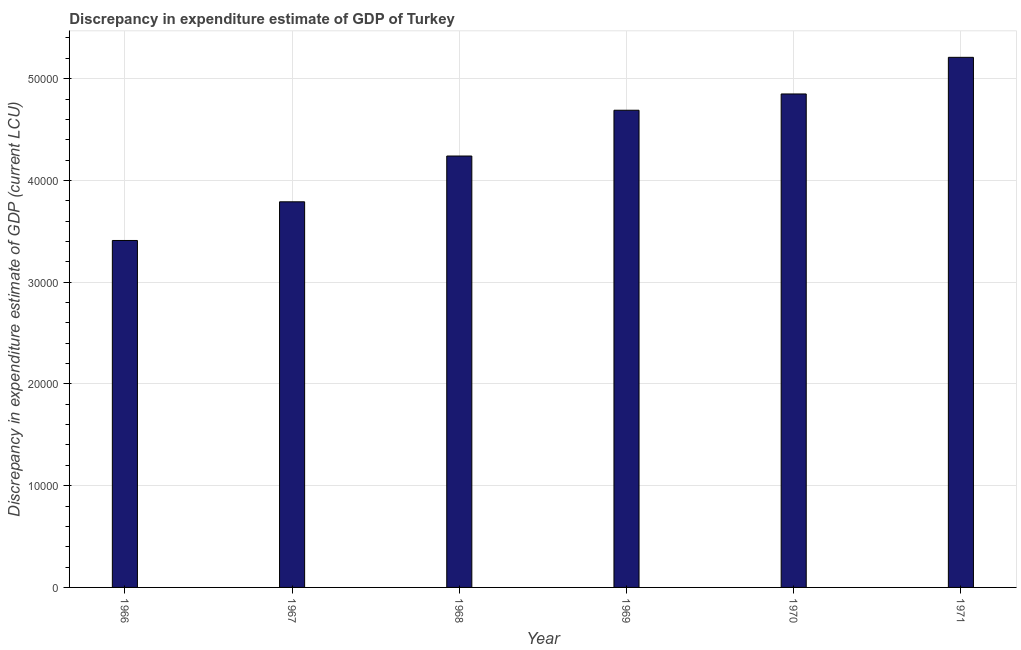Does the graph contain grids?
Provide a succinct answer. Yes. What is the title of the graph?
Make the answer very short. Discrepancy in expenditure estimate of GDP of Turkey. What is the label or title of the Y-axis?
Your answer should be compact. Discrepancy in expenditure estimate of GDP (current LCU). What is the discrepancy in expenditure estimate of gdp in 1968?
Give a very brief answer. 4.24e+04. Across all years, what is the maximum discrepancy in expenditure estimate of gdp?
Keep it short and to the point. 5.21e+04. Across all years, what is the minimum discrepancy in expenditure estimate of gdp?
Provide a succinct answer. 3.41e+04. In which year was the discrepancy in expenditure estimate of gdp maximum?
Your response must be concise. 1971. In which year was the discrepancy in expenditure estimate of gdp minimum?
Offer a very short reply. 1966. What is the sum of the discrepancy in expenditure estimate of gdp?
Keep it short and to the point. 2.62e+05. What is the difference between the discrepancy in expenditure estimate of gdp in 1969 and 1971?
Your response must be concise. -5200. What is the average discrepancy in expenditure estimate of gdp per year?
Offer a terse response. 4.36e+04. What is the median discrepancy in expenditure estimate of gdp?
Give a very brief answer. 4.46e+04. Do a majority of the years between 1967 and 1968 (inclusive) have discrepancy in expenditure estimate of gdp greater than 12000 LCU?
Offer a terse response. Yes. What is the ratio of the discrepancy in expenditure estimate of gdp in 1968 to that in 1970?
Make the answer very short. 0.87. Is the discrepancy in expenditure estimate of gdp in 1967 less than that in 1971?
Provide a short and direct response. Yes. Is the difference between the discrepancy in expenditure estimate of gdp in 1967 and 1968 greater than the difference between any two years?
Make the answer very short. No. What is the difference between the highest and the second highest discrepancy in expenditure estimate of gdp?
Ensure brevity in your answer.  3600. What is the difference between the highest and the lowest discrepancy in expenditure estimate of gdp?
Ensure brevity in your answer.  1.80e+04. How many bars are there?
Offer a terse response. 6. How many years are there in the graph?
Provide a short and direct response. 6. What is the difference between two consecutive major ticks on the Y-axis?
Provide a short and direct response. 10000. Are the values on the major ticks of Y-axis written in scientific E-notation?
Ensure brevity in your answer.  No. What is the Discrepancy in expenditure estimate of GDP (current LCU) in 1966?
Make the answer very short. 3.41e+04. What is the Discrepancy in expenditure estimate of GDP (current LCU) of 1967?
Your answer should be very brief. 3.79e+04. What is the Discrepancy in expenditure estimate of GDP (current LCU) of 1968?
Your answer should be very brief. 4.24e+04. What is the Discrepancy in expenditure estimate of GDP (current LCU) in 1969?
Offer a very short reply. 4.69e+04. What is the Discrepancy in expenditure estimate of GDP (current LCU) of 1970?
Offer a terse response. 4.85e+04. What is the Discrepancy in expenditure estimate of GDP (current LCU) in 1971?
Provide a short and direct response. 5.21e+04. What is the difference between the Discrepancy in expenditure estimate of GDP (current LCU) in 1966 and 1967?
Provide a succinct answer. -3800. What is the difference between the Discrepancy in expenditure estimate of GDP (current LCU) in 1966 and 1968?
Your answer should be very brief. -8300. What is the difference between the Discrepancy in expenditure estimate of GDP (current LCU) in 1966 and 1969?
Your answer should be very brief. -1.28e+04. What is the difference between the Discrepancy in expenditure estimate of GDP (current LCU) in 1966 and 1970?
Offer a very short reply. -1.44e+04. What is the difference between the Discrepancy in expenditure estimate of GDP (current LCU) in 1966 and 1971?
Offer a very short reply. -1.80e+04. What is the difference between the Discrepancy in expenditure estimate of GDP (current LCU) in 1967 and 1968?
Make the answer very short. -4500. What is the difference between the Discrepancy in expenditure estimate of GDP (current LCU) in 1967 and 1969?
Your answer should be compact. -9000. What is the difference between the Discrepancy in expenditure estimate of GDP (current LCU) in 1967 and 1970?
Give a very brief answer. -1.06e+04. What is the difference between the Discrepancy in expenditure estimate of GDP (current LCU) in 1967 and 1971?
Your answer should be compact. -1.42e+04. What is the difference between the Discrepancy in expenditure estimate of GDP (current LCU) in 1968 and 1969?
Ensure brevity in your answer.  -4500. What is the difference between the Discrepancy in expenditure estimate of GDP (current LCU) in 1968 and 1970?
Ensure brevity in your answer.  -6100. What is the difference between the Discrepancy in expenditure estimate of GDP (current LCU) in 1968 and 1971?
Offer a very short reply. -9700. What is the difference between the Discrepancy in expenditure estimate of GDP (current LCU) in 1969 and 1970?
Provide a short and direct response. -1600. What is the difference between the Discrepancy in expenditure estimate of GDP (current LCU) in 1969 and 1971?
Your answer should be compact. -5200. What is the difference between the Discrepancy in expenditure estimate of GDP (current LCU) in 1970 and 1971?
Offer a terse response. -3600. What is the ratio of the Discrepancy in expenditure estimate of GDP (current LCU) in 1966 to that in 1967?
Provide a short and direct response. 0.9. What is the ratio of the Discrepancy in expenditure estimate of GDP (current LCU) in 1966 to that in 1968?
Make the answer very short. 0.8. What is the ratio of the Discrepancy in expenditure estimate of GDP (current LCU) in 1966 to that in 1969?
Give a very brief answer. 0.73. What is the ratio of the Discrepancy in expenditure estimate of GDP (current LCU) in 1966 to that in 1970?
Your answer should be very brief. 0.7. What is the ratio of the Discrepancy in expenditure estimate of GDP (current LCU) in 1966 to that in 1971?
Ensure brevity in your answer.  0.66. What is the ratio of the Discrepancy in expenditure estimate of GDP (current LCU) in 1967 to that in 1968?
Make the answer very short. 0.89. What is the ratio of the Discrepancy in expenditure estimate of GDP (current LCU) in 1967 to that in 1969?
Keep it short and to the point. 0.81. What is the ratio of the Discrepancy in expenditure estimate of GDP (current LCU) in 1967 to that in 1970?
Offer a very short reply. 0.78. What is the ratio of the Discrepancy in expenditure estimate of GDP (current LCU) in 1967 to that in 1971?
Offer a terse response. 0.73. What is the ratio of the Discrepancy in expenditure estimate of GDP (current LCU) in 1968 to that in 1969?
Your response must be concise. 0.9. What is the ratio of the Discrepancy in expenditure estimate of GDP (current LCU) in 1968 to that in 1970?
Offer a terse response. 0.87. What is the ratio of the Discrepancy in expenditure estimate of GDP (current LCU) in 1968 to that in 1971?
Give a very brief answer. 0.81. What is the ratio of the Discrepancy in expenditure estimate of GDP (current LCU) in 1969 to that in 1971?
Provide a short and direct response. 0.9. What is the ratio of the Discrepancy in expenditure estimate of GDP (current LCU) in 1970 to that in 1971?
Ensure brevity in your answer.  0.93. 